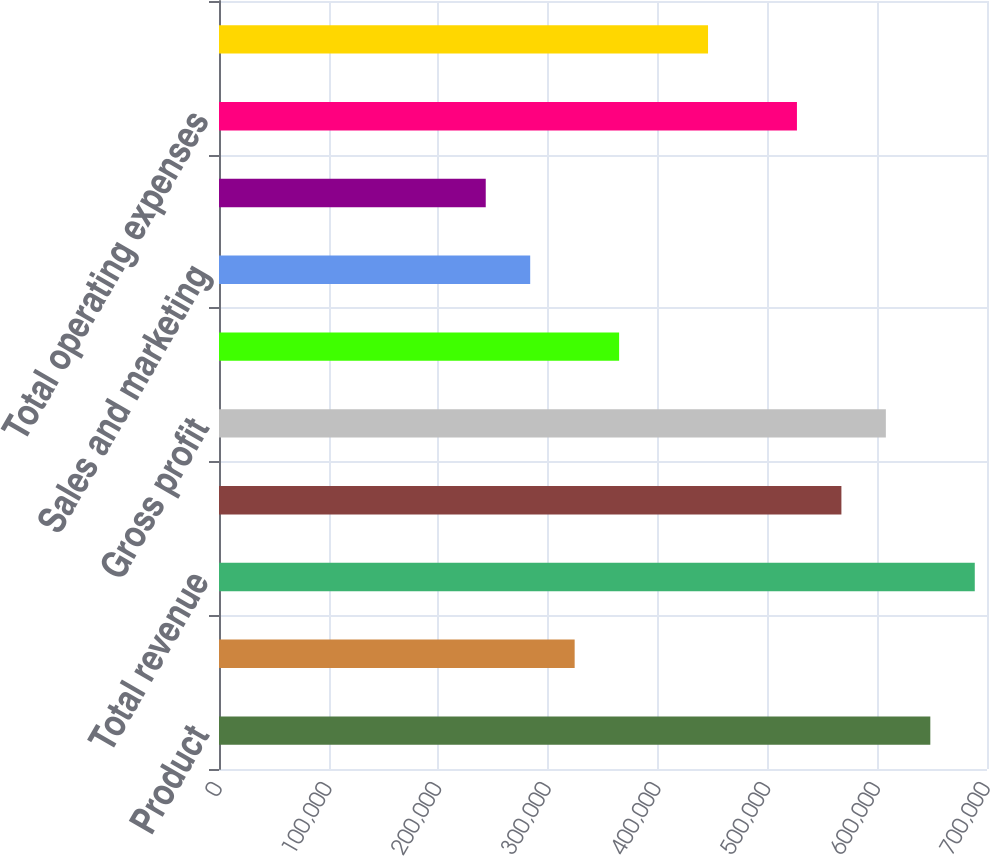Convert chart to OTSL. <chart><loc_0><loc_0><loc_500><loc_500><bar_chart><fcel>Product<fcel>Service<fcel>Total revenue<fcel>Total cost of revenue<fcel>Gross profit<fcel>Research and development<fcel>Sales and marketing<fcel>General and administrative<fcel>Total operating expenses<fcel>Income from operations<nl><fcel>648337<fcel>324169<fcel>688858<fcel>567295<fcel>607816<fcel>364690<fcel>283648<fcel>243127<fcel>526774<fcel>445732<nl></chart> 